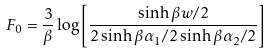Convert formula to latex. <formula><loc_0><loc_0><loc_500><loc_500>F _ { 0 } = \frac { 3 } { \beta } \log \left [ \frac { \sinh \beta w / 2 } { 2 \sinh \beta \alpha _ { 1 } / 2 \sinh \beta \alpha _ { 2 } / 2 } \right ]</formula> 